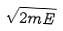Convert formula to latex. <formula><loc_0><loc_0><loc_500><loc_500>\sqrt { 2 m E }</formula> 